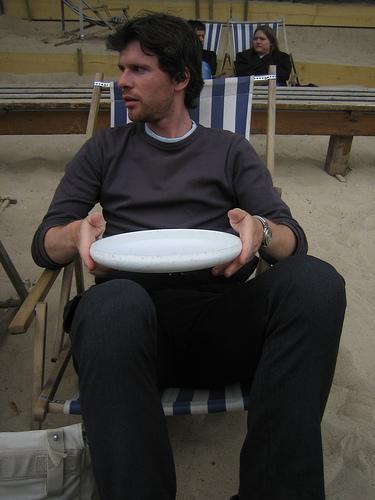How many people are in this picture?
Give a very brief answer. 3. How many people are in the picture?
Give a very brief answer. 2. How many frisbees are there?
Give a very brief answer. 1. 